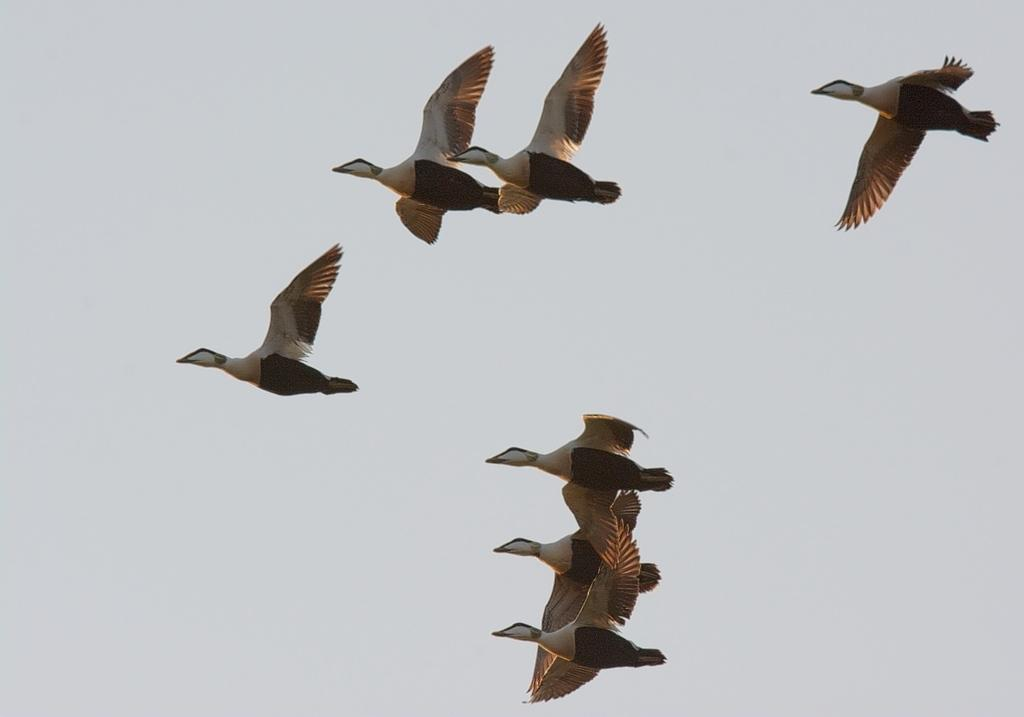What type of animals can be seen in the image? Birds can be seen in the image. What are the birds doing in the image? The birds are flying in the sky. What type of muscle is visible on the birds in the image? There is no specific muscle visible on the birds in the image; we can only see their overall shape and movement. 